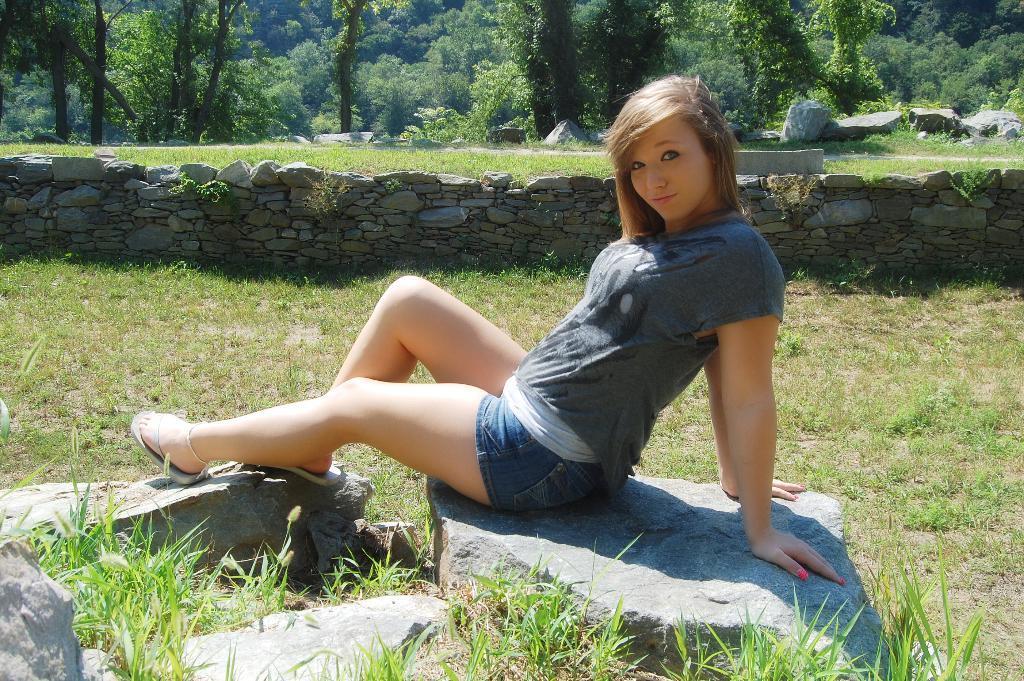Could you give a brief overview of what you see in this image? In this image, we can see a person sitting. We can see the ground. We can see some grass, plants, trees, stones. We can also see the wall. 